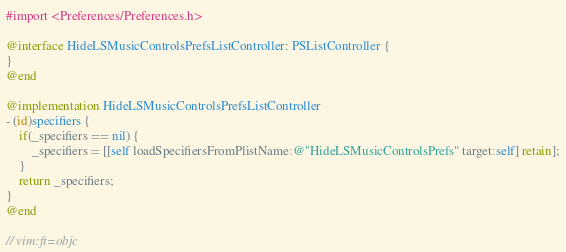Convert code to text. <code><loc_0><loc_0><loc_500><loc_500><_ObjectiveC_>#import <Preferences/Preferences.h>

@interface HideLSMusicControlsPrefsListController: PSListController {
}
@end

@implementation HideLSMusicControlsPrefsListController
- (id)specifiers {
	if(_specifiers == nil) {
		_specifiers = [[self loadSpecifiersFromPlistName:@"HideLSMusicControlsPrefs" target:self] retain];
	}
	return _specifiers;
}
@end

// vim:ft=objc
</code> 